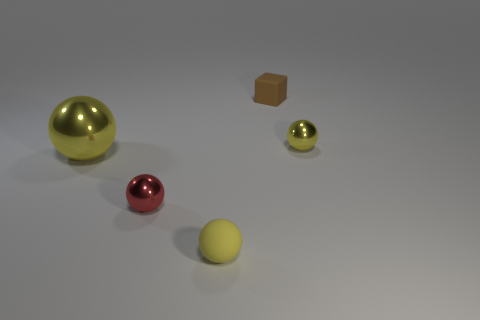Is there anything else that is made of the same material as the big object?
Your answer should be compact. Yes. Is the number of large shiny things that are right of the large object greater than the number of brown cubes on the left side of the red thing?
Keep it short and to the point. No. There is a tiny yellow object that is the same material as the big yellow thing; what shape is it?
Offer a very short reply. Sphere. How many other things are there of the same shape as the brown object?
Your answer should be very brief. 0. What is the shape of the small rubber object that is in front of the brown matte thing?
Provide a succinct answer. Sphere. The big sphere has what color?
Your response must be concise. Yellow. How many other objects are there of the same size as the brown thing?
Offer a terse response. 3. What material is the yellow ball that is right of the small matte object that is left of the cube?
Offer a terse response. Metal. Is the size of the yellow rubber sphere the same as the metallic sphere that is left of the tiny red ball?
Your response must be concise. No. Is there a small ball of the same color as the large object?
Keep it short and to the point. Yes. 